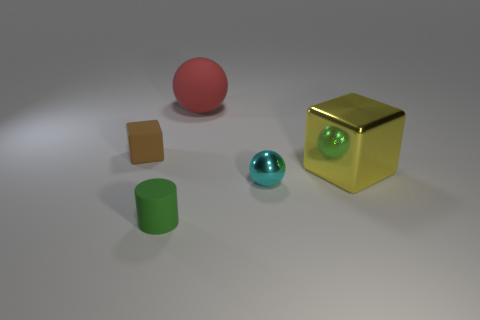Add 3 small red blocks. How many objects exist? 8 Subtract all yellow blocks. How many blocks are left? 1 Subtract all cylinders. How many objects are left? 4 Subtract 1 cylinders. How many cylinders are left? 0 Subtract all brown blocks. Subtract all green cylinders. How many blocks are left? 1 Subtract all cyan spheres. How many purple cubes are left? 0 Subtract all cyan matte things. Subtract all brown things. How many objects are left? 4 Add 1 tiny brown objects. How many tiny brown objects are left? 2 Add 3 metal balls. How many metal balls exist? 4 Subtract 0 red cylinders. How many objects are left? 5 